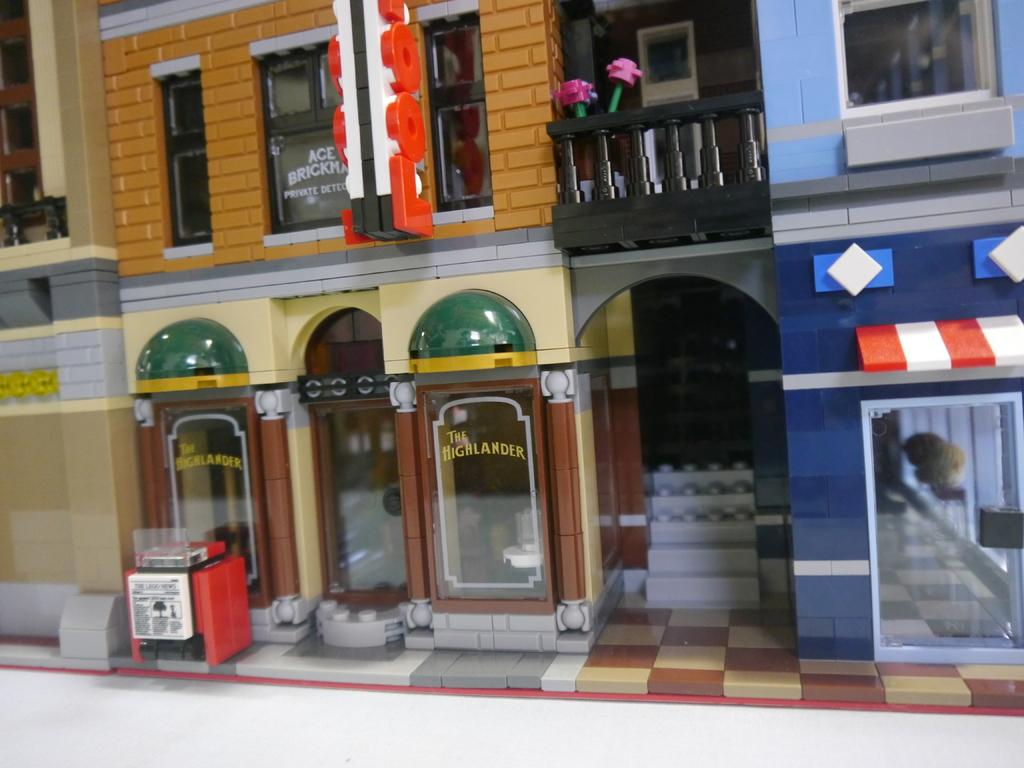What type of structures are present in the image? There are miniature buildings in the image. What features do the miniature buildings have? The miniature buildings have windows, glass walls, stairs, and railing. Are there any natural elements in the miniature? Yes, there are flowers in the miniature. What other objects can be seen in the miniature? There are other objects in the miniature, but their specific details are not mentioned in the provided facts. What is the place of desire for the lizards in the image? There are no lizards present in the image, so it is not possible to determine their place of desire. 